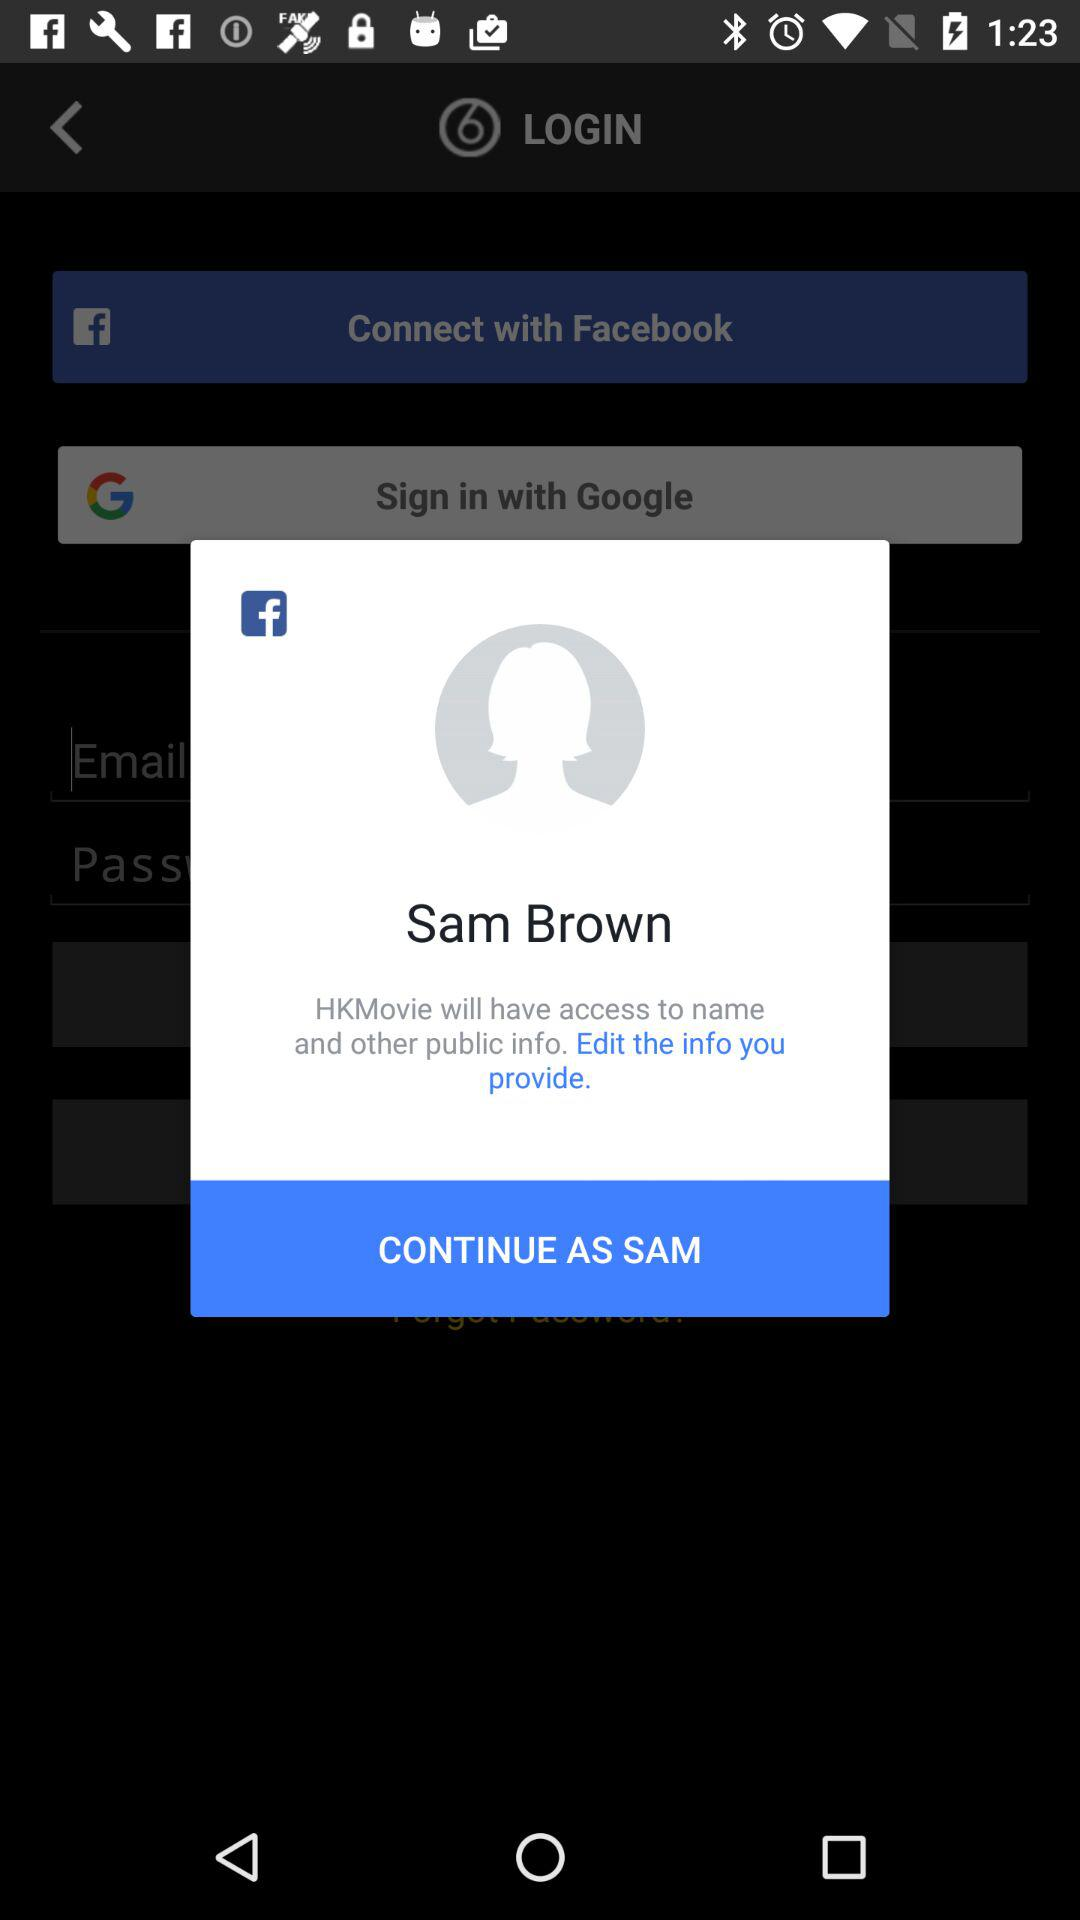What application will have access to my name and other public information? The application is "HKMovie". 